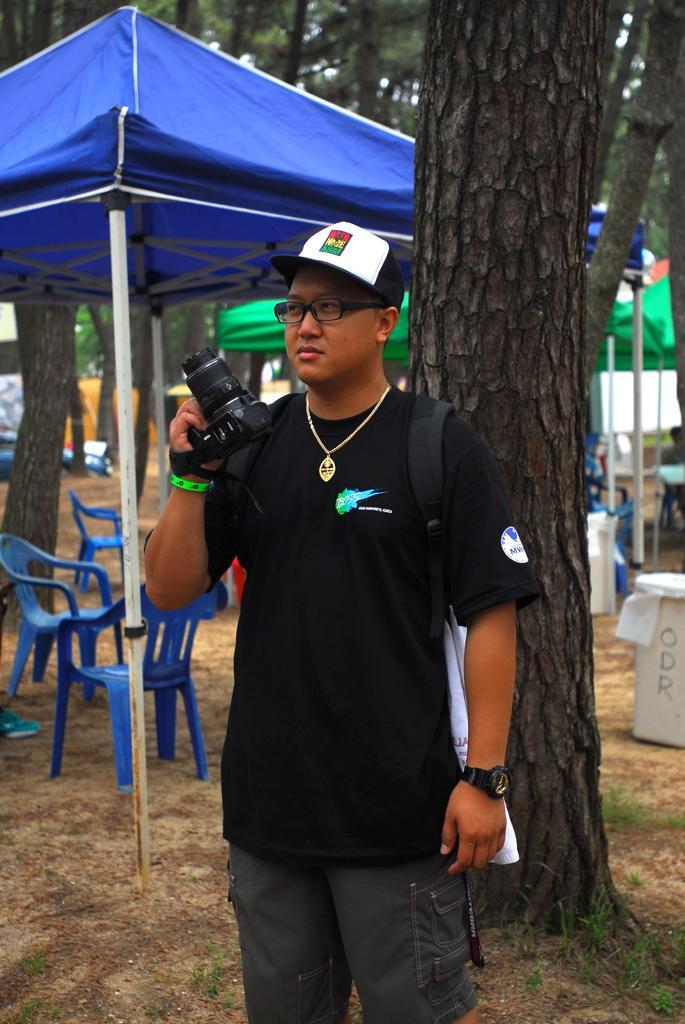Please provide a concise description of this image. In this image, I can see a person standing and holding a camera. Behind the person, I can see chairs, canopy tents, trees and few objects on the ground. 